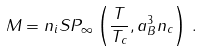Convert formula to latex. <formula><loc_0><loc_0><loc_500><loc_500>M = n _ { i } S { P } _ { \infty } \left ( \frac { T } { T _ { c } } , a _ { B } ^ { 3 } n _ { c } \right ) \, .</formula> 